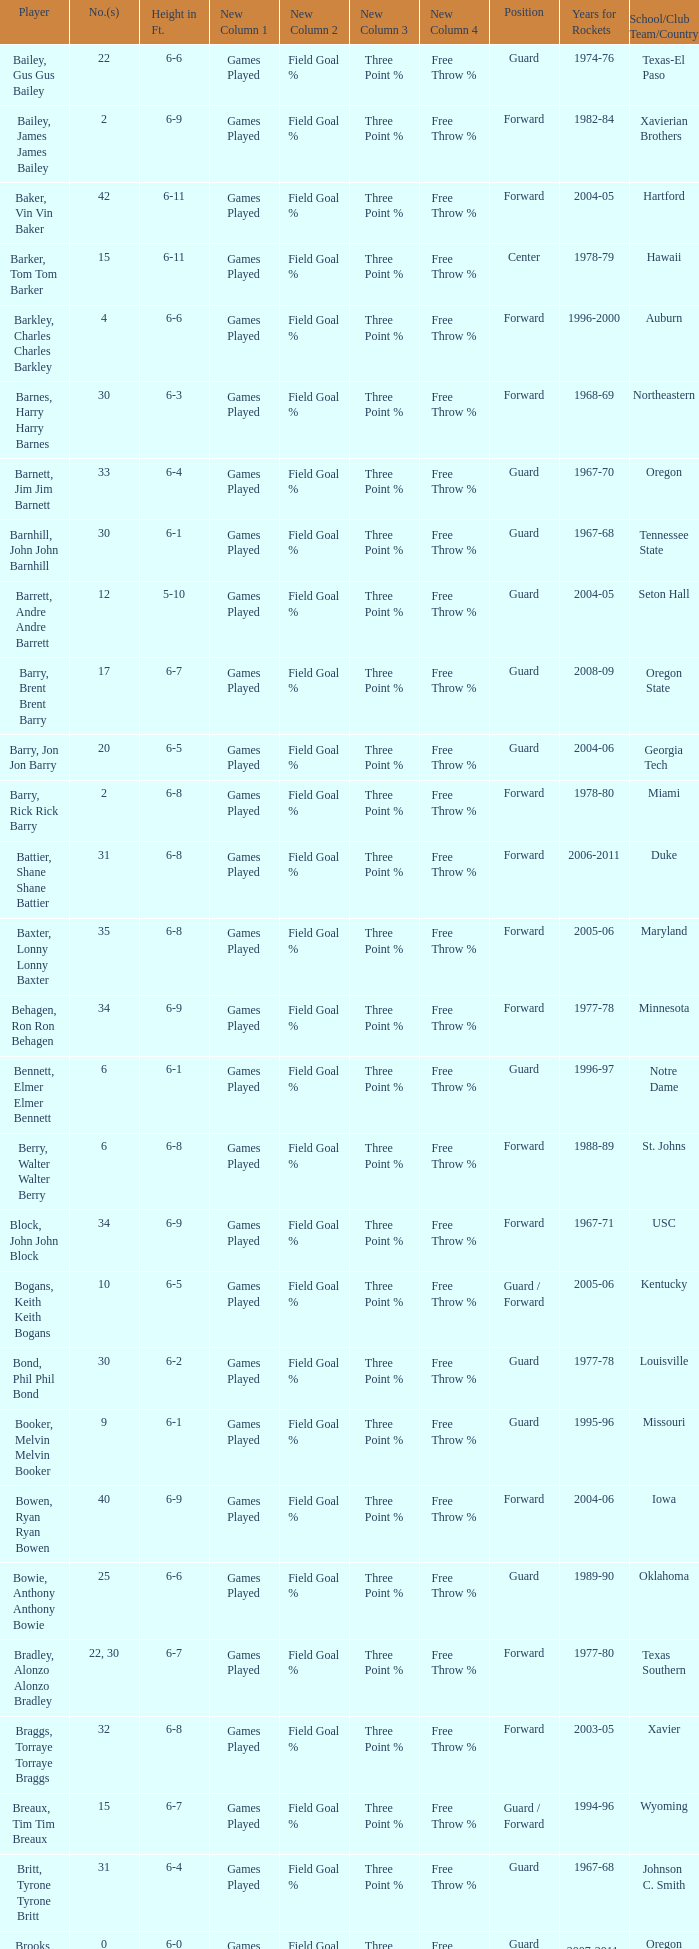What school did the forward whose number is 10 belong to? Arizona. 